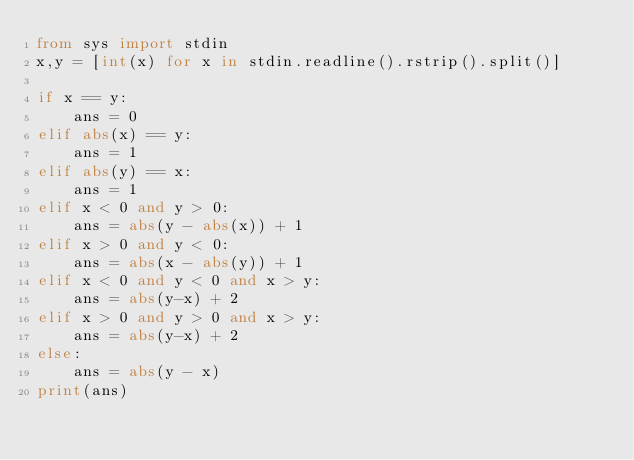Convert code to text. <code><loc_0><loc_0><loc_500><loc_500><_Python_>from sys import stdin
x,y = [int(x) for x in stdin.readline().rstrip().split()]

if x == y:
    ans = 0
elif abs(x) == y:
    ans = 1
elif abs(y) == x:
    ans = 1 
elif x < 0 and y > 0:
    ans = abs(y - abs(x)) + 1
elif x > 0 and y < 0:
    ans = abs(x - abs(y)) + 1
elif x < 0 and y < 0 and x > y:
    ans = abs(y-x) + 2
elif x > 0 and y > 0 and x > y:
    ans = abs(y-x) + 2 
else:
    ans = abs(y - x)
print(ans)</code> 